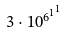Convert formula to latex. <formula><loc_0><loc_0><loc_500><loc_500>3 \cdot 1 0 ^ { { 6 ^ { 1 } } ^ { 1 } }</formula> 